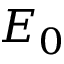Convert formula to latex. <formula><loc_0><loc_0><loc_500><loc_500>E _ { 0 }</formula> 